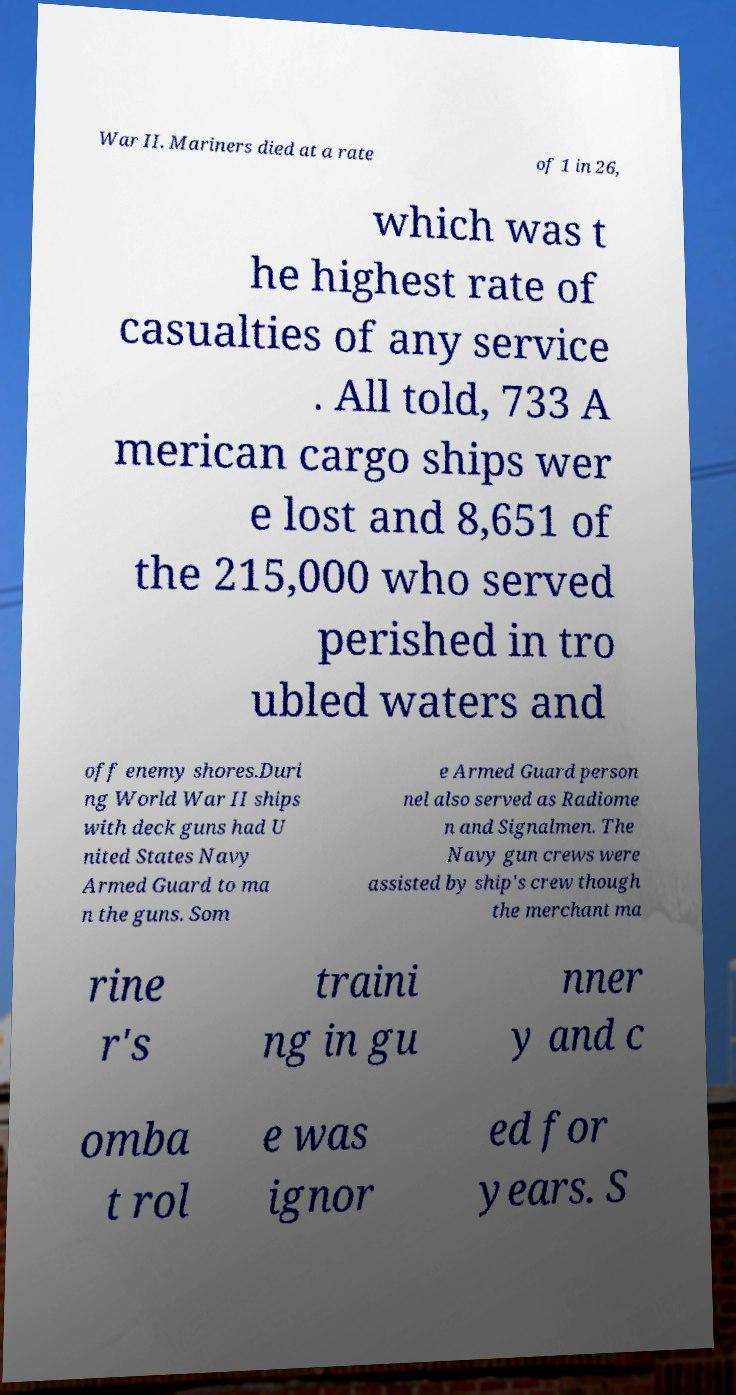Please read and relay the text visible in this image. What does it say? War II. Mariners died at a rate of 1 in 26, which was t he highest rate of casualties of any service . All told, 733 A merican cargo ships wer e lost and 8,651 of the 215,000 who served perished in tro ubled waters and off enemy shores.Duri ng World War II ships with deck guns had U nited States Navy Armed Guard to ma n the guns. Som e Armed Guard person nel also served as Radiome n and Signalmen. The Navy gun crews were assisted by ship's crew though the merchant ma rine r's traini ng in gu nner y and c omba t rol e was ignor ed for years. S 